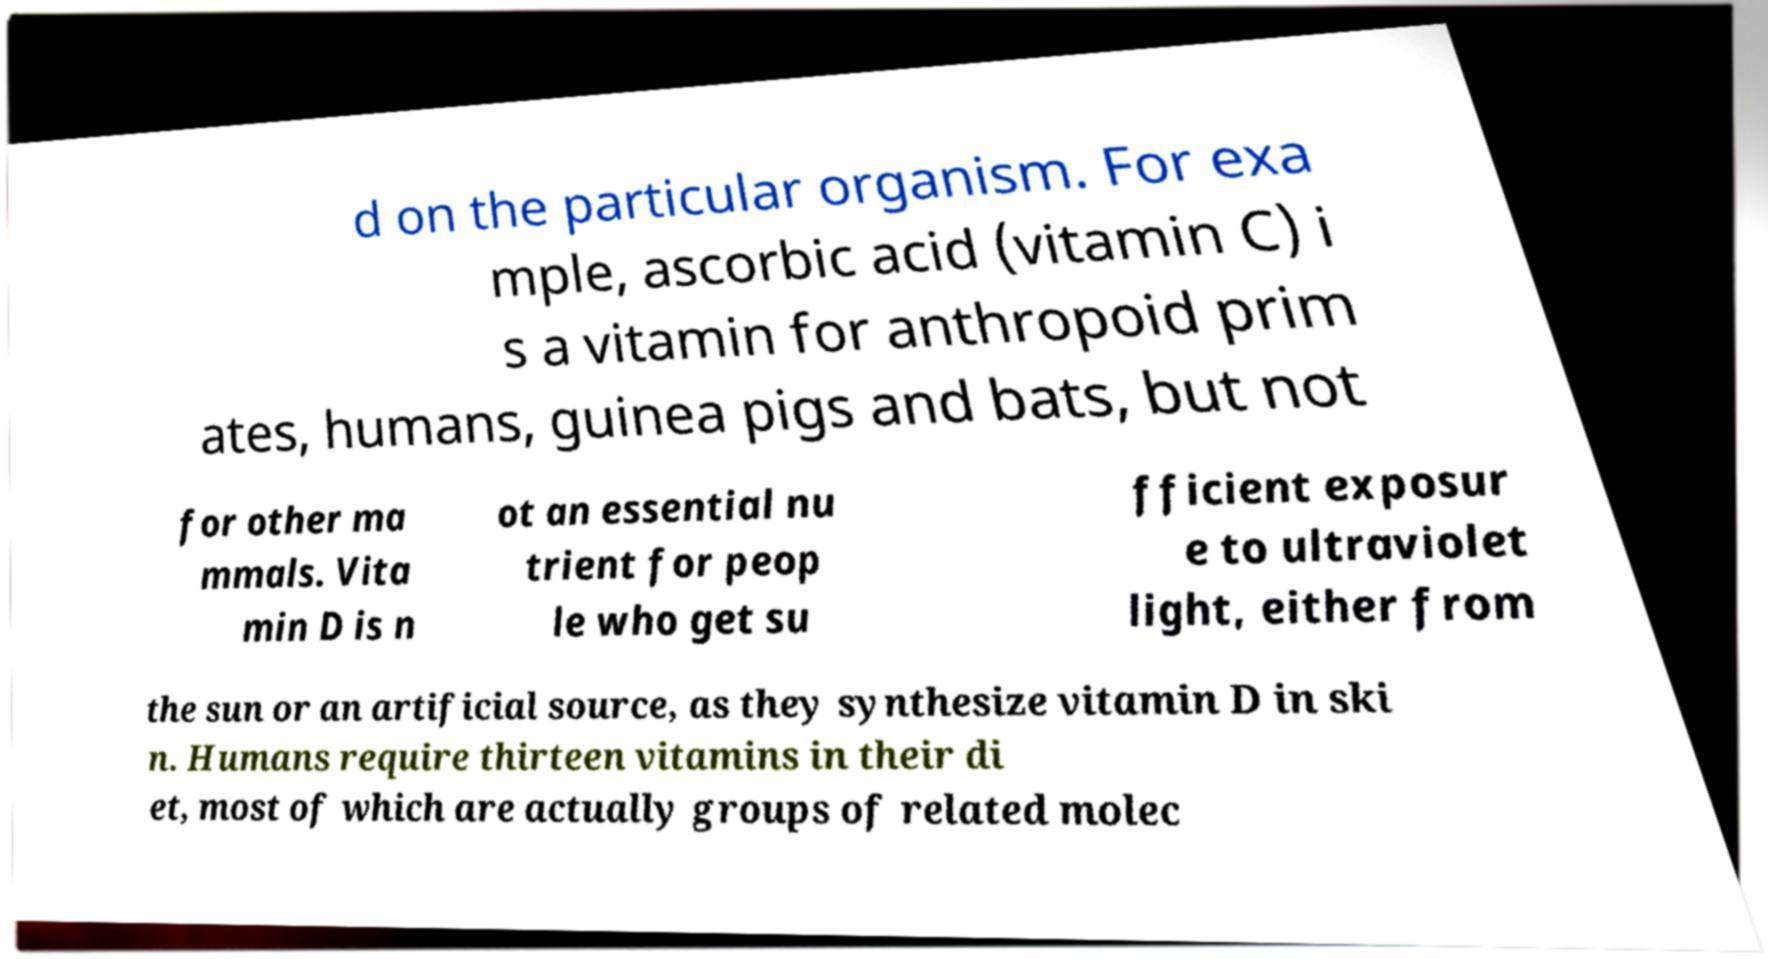Could you extract and type out the text from this image? d on the particular organism. For exa mple, ascorbic acid (vitamin C) i s a vitamin for anthropoid prim ates, humans, guinea pigs and bats, but not for other ma mmals. Vita min D is n ot an essential nu trient for peop le who get su fficient exposur e to ultraviolet light, either from the sun or an artificial source, as they synthesize vitamin D in ski n. Humans require thirteen vitamins in their di et, most of which are actually groups of related molec 